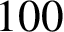Convert formula to latex. <formula><loc_0><loc_0><loc_500><loc_500>1 0 0</formula> 